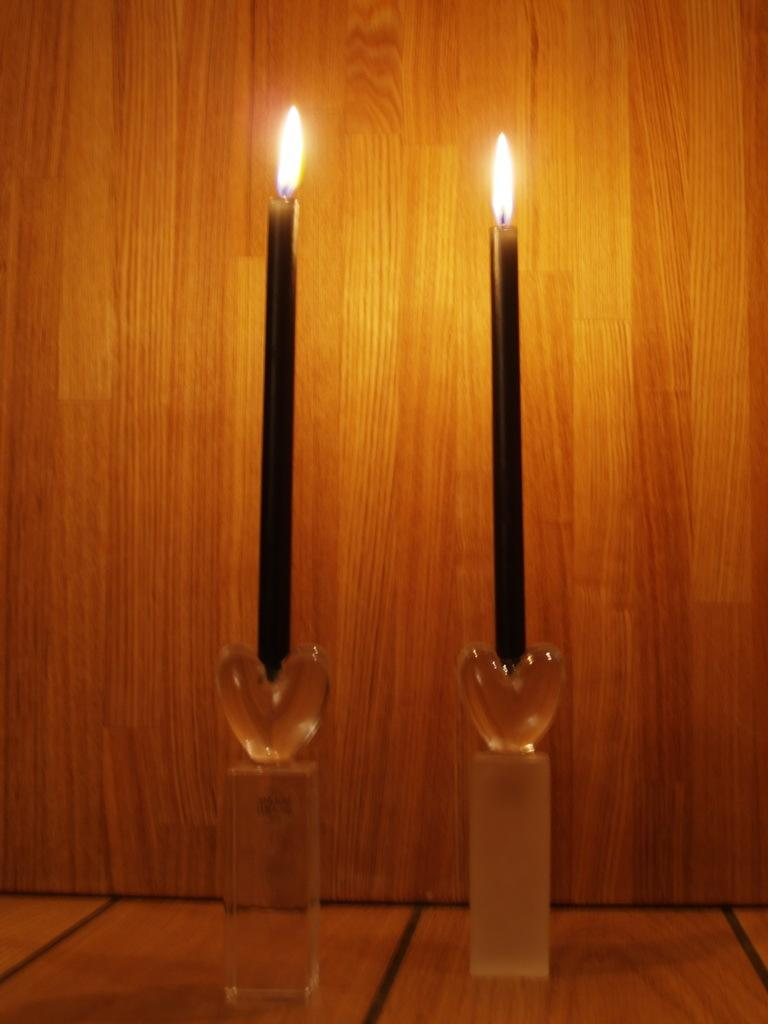What objects with flames can be seen in the image? There are two candles with flames in the image. Where are the candles placed? The candles are on a candle stand. What material is the candle stand made of? The candle stand appears to be made of wood. What type of surface is visible in the image? The image shows a floor. What type of quill is being used by the minister to make a payment in the image? There is no quill, minister, or payment present in the image. 